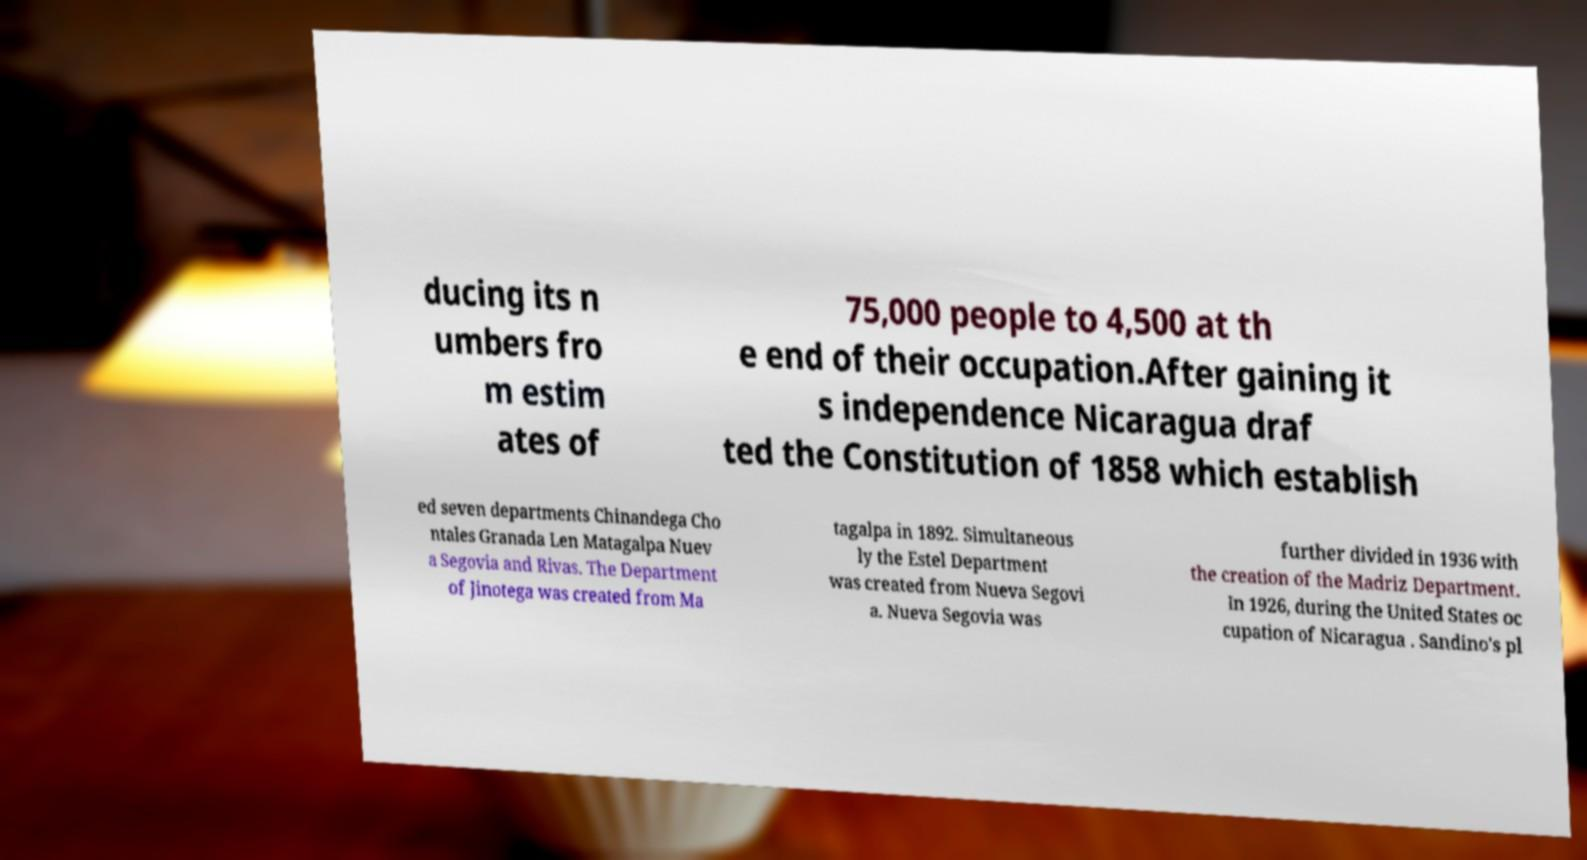For documentation purposes, I need the text within this image transcribed. Could you provide that? ducing its n umbers fro m estim ates of 75,000 people to 4,500 at th e end of their occupation.After gaining it s independence Nicaragua draf ted the Constitution of 1858 which establish ed seven departments Chinandega Cho ntales Granada Len Matagalpa Nuev a Segovia and Rivas. The Department of Jinotega was created from Ma tagalpa in 1892. Simultaneous ly the Estel Department was created from Nueva Segovi a. Nueva Segovia was further divided in 1936 with the creation of the Madriz Department. In 1926, during the United States oc cupation of Nicaragua . Sandino's pl 